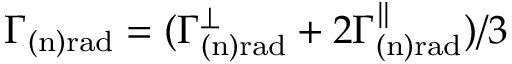<formula> <loc_0><loc_0><loc_500><loc_500>\Gamma _ { ( n ) r a d } = ( \Gamma _ { ( n ) r a d } ^ { \perp } + 2 \Gamma _ { ( n ) r a d } ^ { \| } ) / 3</formula> 